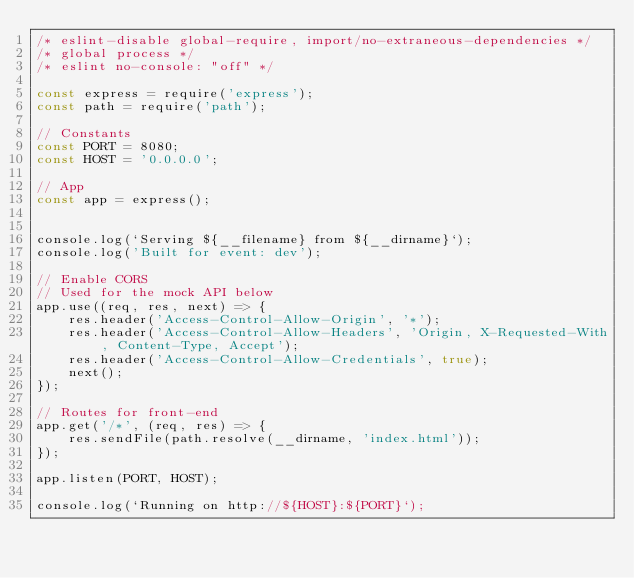<code> <loc_0><loc_0><loc_500><loc_500><_JavaScript_>/* eslint-disable global-require, import/no-extraneous-dependencies */
/* global process */
/* eslint no-console: "off" */

const express = require('express');
const path = require('path');

// Constants
const PORT = 8080;
const HOST = '0.0.0.0';

// App
const app = express();


console.log(`Serving ${__filename} from ${__dirname}`);
console.log('Built for event: dev');

// Enable CORS
// Used for the mock API below
app.use((req, res, next) => {
    res.header('Access-Control-Allow-Origin', '*');
    res.header('Access-Control-Allow-Headers', 'Origin, X-Requested-With, Content-Type, Accept');
    res.header('Access-Control-Allow-Credentials', true);
    next();
});

// Routes for front-end
app.get('/*', (req, res) => {
    res.sendFile(path.resolve(__dirname, 'index.html'));
});

app.listen(PORT, HOST);

console.log(`Running on http://${HOST}:${PORT}`);
</code> 